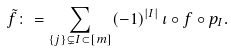Convert formula to latex. <formula><loc_0><loc_0><loc_500><loc_500>\tilde { f } \colon = \sum _ { \{ j \} \subsetneq I \subset [ m ] } ( - 1 ) ^ { | I | } \, \iota \circ f \circ p _ { I } .</formula> 